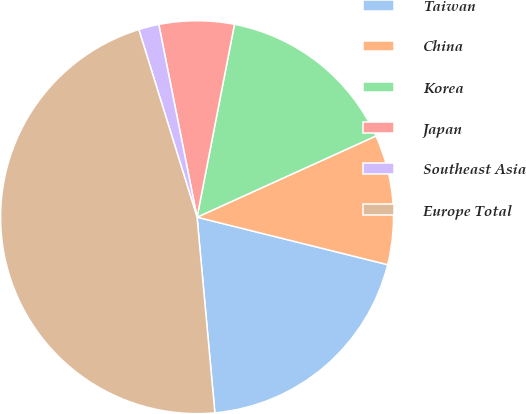Convert chart to OTSL. <chart><loc_0><loc_0><loc_500><loc_500><pie_chart><fcel>Taiwan<fcel>China<fcel>Korea<fcel>Japan<fcel>Southeast Asia<fcel>Europe Total<nl><fcel>19.67%<fcel>10.67%<fcel>15.17%<fcel>6.17%<fcel>1.67%<fcel>46.66%<nl></chart> 